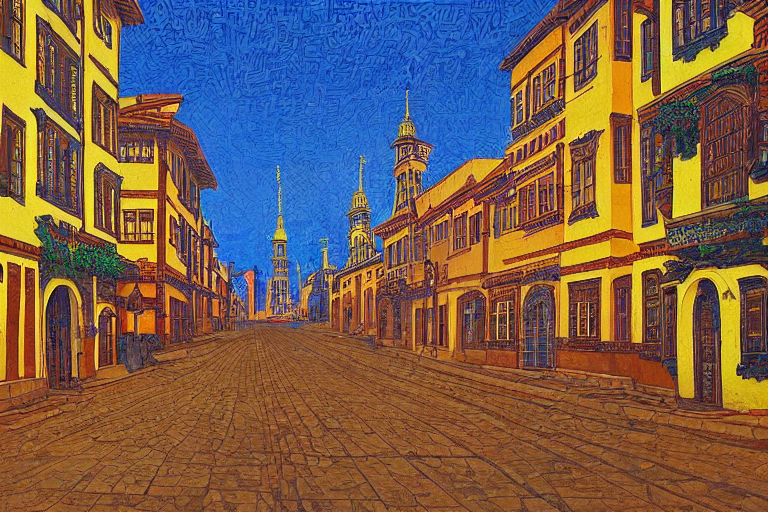Can you describe the artistic style used in this image? The image features a unique, stylized technique that resembles the artistic approach of Vincent van Gogh, characterized by bold, dynamic brush strokes and vivid contrasting colors. It offers a sense of depth and texture, which invigorates the urban scene with an energetic yet harmonious ambiance. What does the color palette tell you about the mood of the image? The color palette of bright yellows, deep blues, and warm oranges creates a lively and inviting mood. The use of such contrasting colors can be seen to imbue the streetscape with vibrancy and a sense of excitement, suggesting that the artist aimed to evoke a feeling of optimism through their choice of hues. 